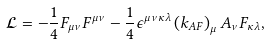<formula> <loc_0><loc_0><loc_500><loc_500>\mathcal { L } = - \frac { 1 } { 4 } F _ { \mu \nu } F ^ { \mu \nu } - \frac { 1 } { 4 } \epsilon ^ { \mu \nu \kappa \lambda } \left ( k _ { A F } \right ) _ { \mu } A _ { \nu } F _ { \kappa \lambda } ,</formula> 